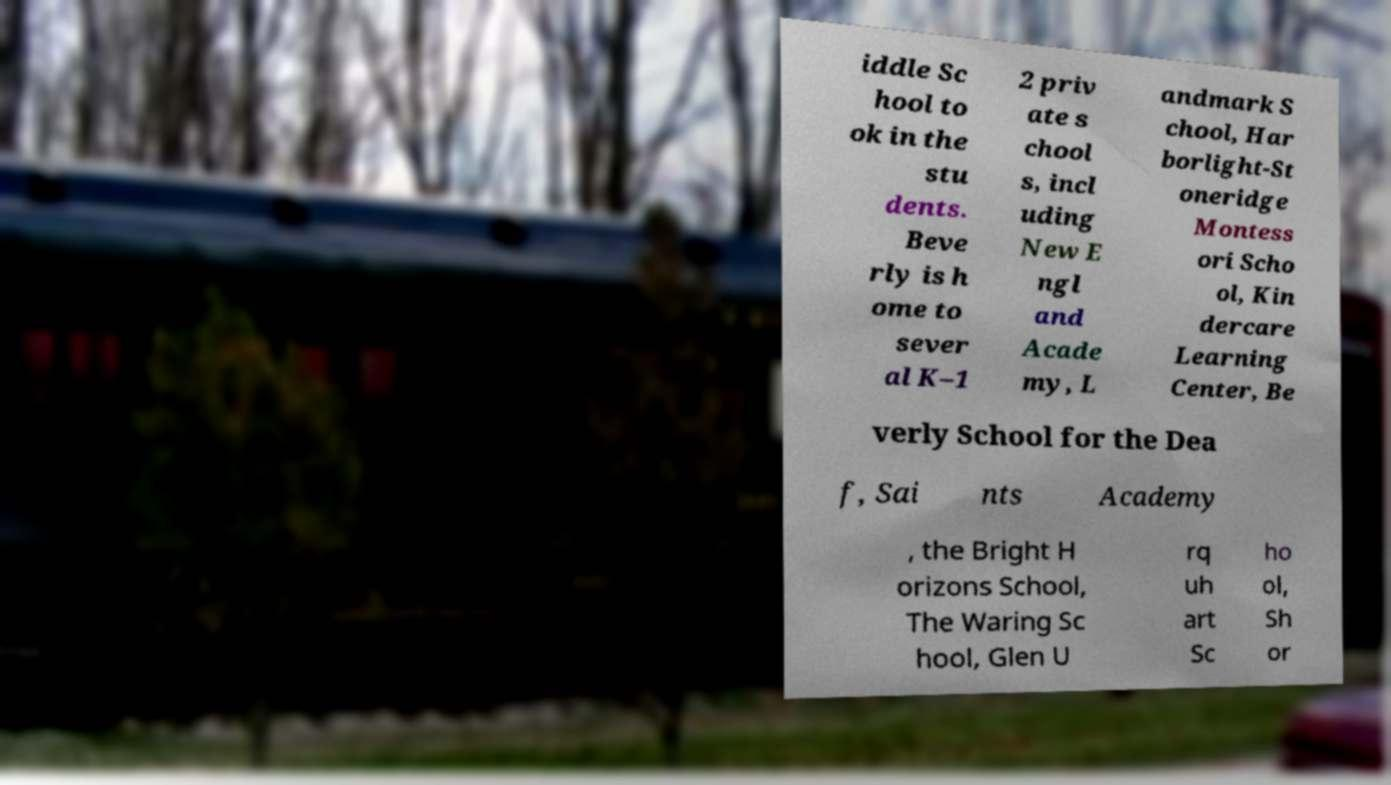There's text embedded in this image that I need extracted. Can you transcribe it verbatim? iddle Sc hool to ok in the stu dents. Beve rly is h ome to sever al K–1 2 priv ate s chool s, incl uding New E ngl and Acade my, L andmark S chool, Har borlight-St oneridge Montess ori Scho ol, Kin dercare Learning Center, Be verly School for the Dea f, Sai nts Academy , the Bright H orizons School, The Waring Sc hool, Glen U rq uh art Sc ho ol, Sh or 